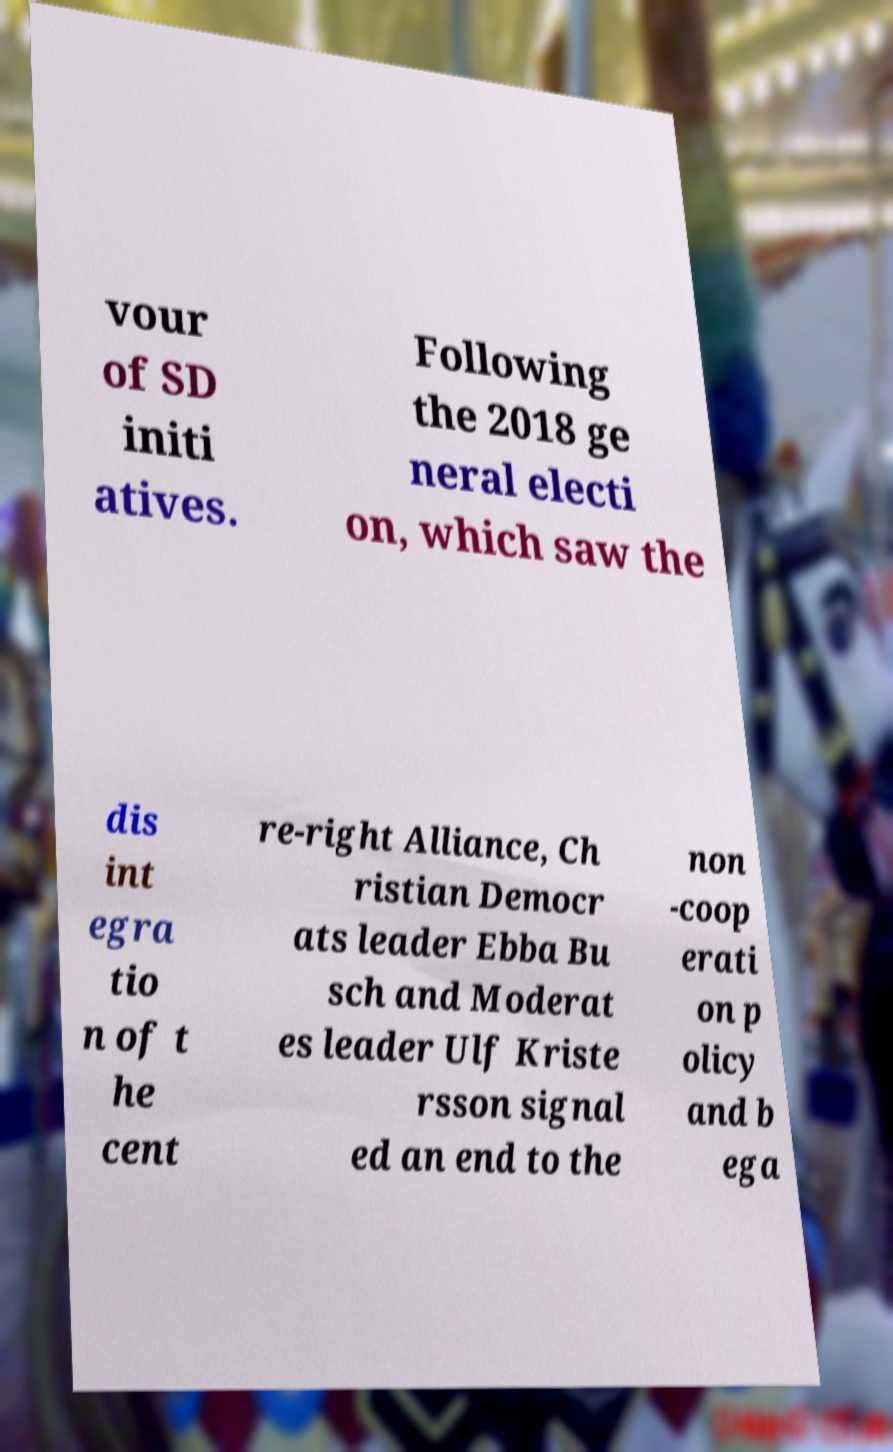For documentation purposes, I need the text within this image transcribed. Could you provide that? vour of SD initi atives. Following the 2018 ge neral electi on, which saw the dis int egra tio n of t he cent re-right Alliance, Ch ristian Democr ats leader Ebba Bu sch and Moderat es leader Ulf Kriste rsson signal ed an end to the non -coop erati on p olicy and b ega 